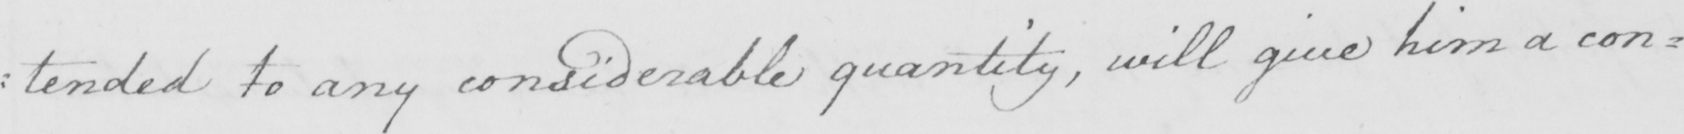Can you read and transcribe this handwriting? : tended to any considerable quantity  , will give him a con= 